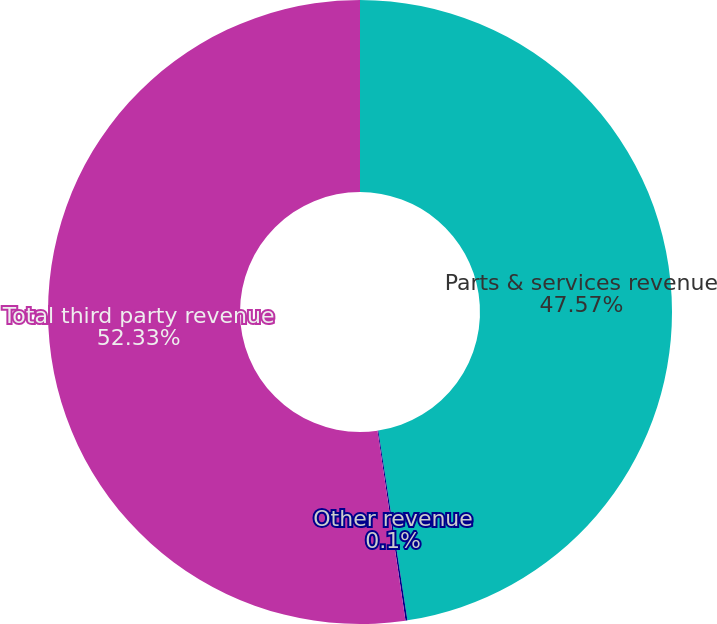Convert chart. <chart><loc_0><loc_0><loc_500><loc_500><pie_chart><fcel>Parts & services revenue<fcel>Other revenue<fcel>Total third party revenue<nl><fcel>47.57%<fcel>0.1%<fcel>52.33%<nl></chart> 